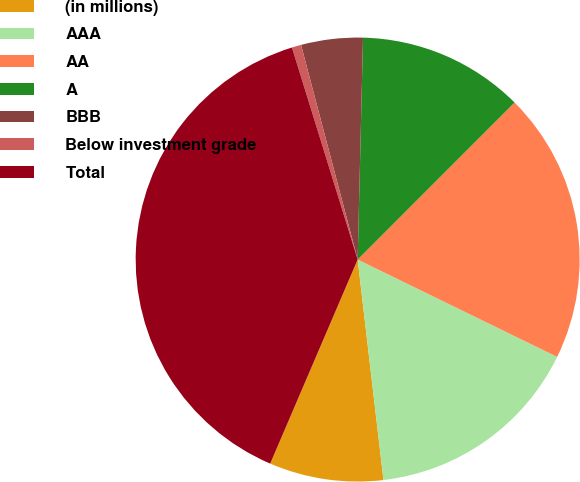<chart> <loc_0><loc_0><loc_500><loc_500><pie_chart><fcel>(in millions)<fcel>AAA<fcel>AA<fcel>A<fcel>BBB<fcel>Below investment grade<fcel>Total<nl><fcel>8.3%<fcel>15.92%<fcel>19.73%<fcel>12.11%<fcel>4.49%<fcel>0.68%<fcel>38.77%<nl></chart> 